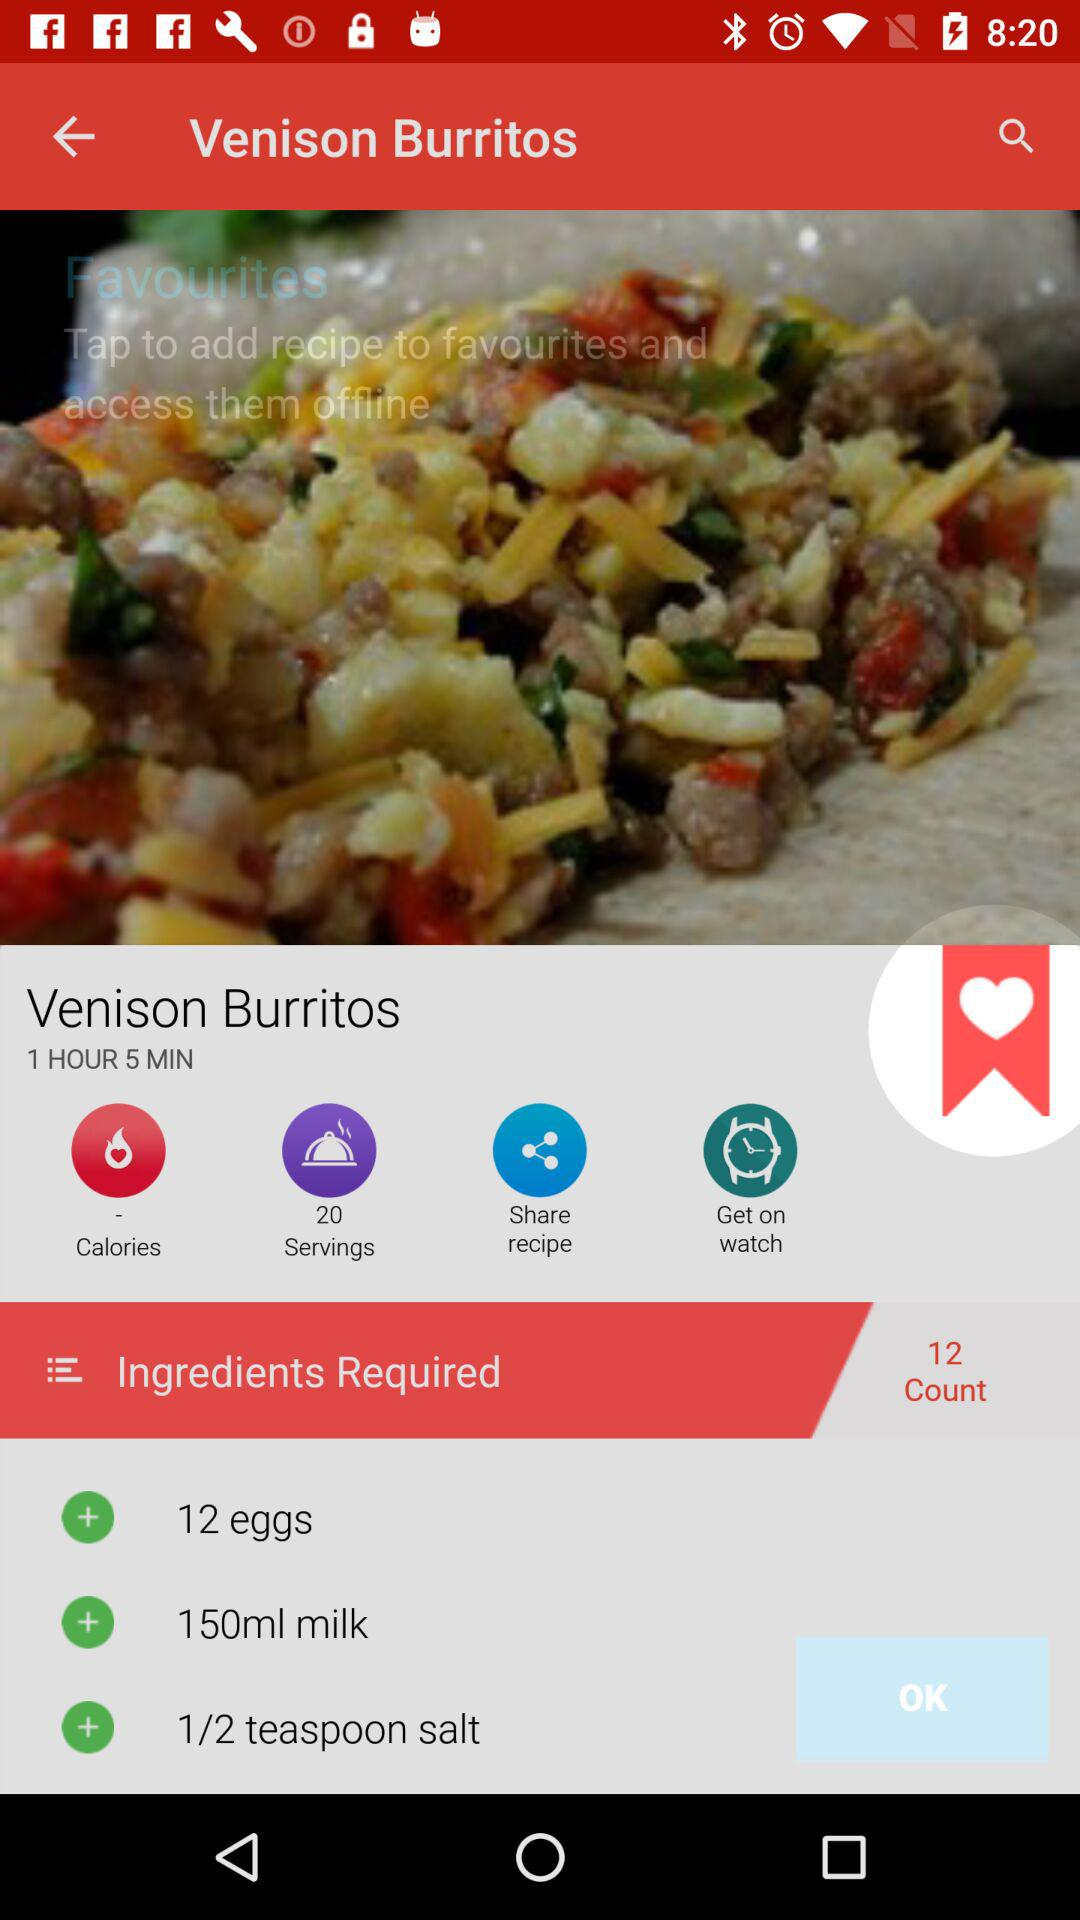How many serving does the recipe make?
Answer the question using a single word or phrase. 20 